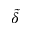Convert formula to latex. <formula><loc_0><loc_0><loc_500><loc_500>\widetilde { \delta }</formula> 